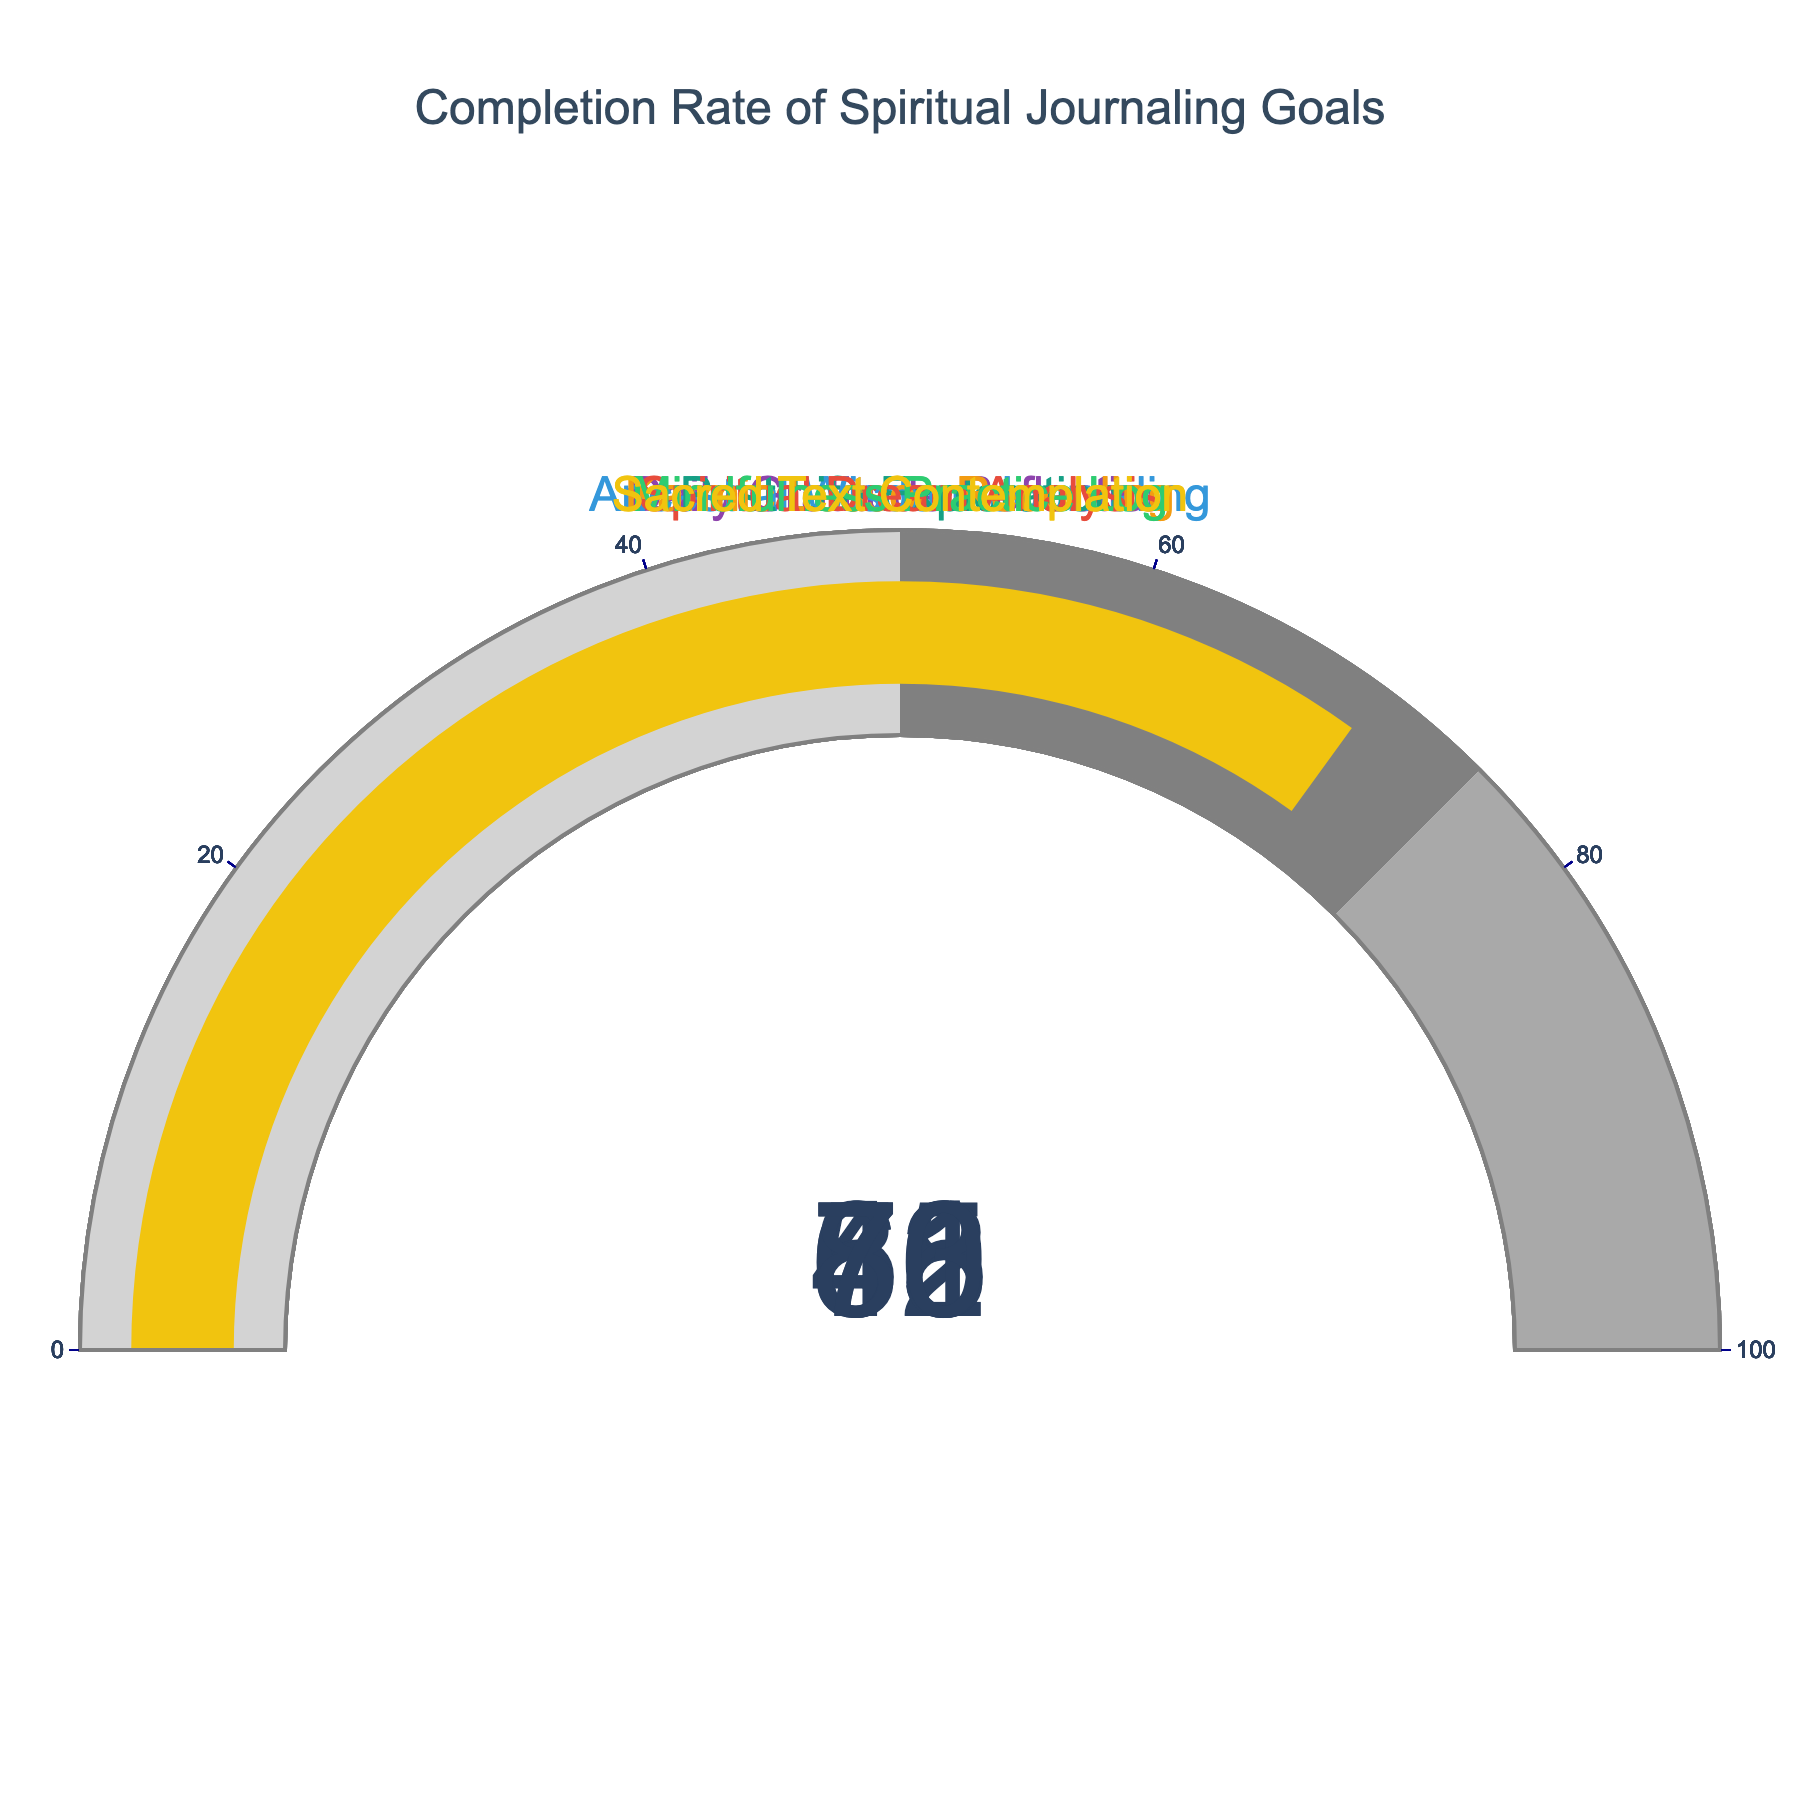What's the highest completion rate displayed on the gauge charts? Identify the gauge with the highest value. The Mindfulness Practice Log has a completion rate of 83, which is the highest rate shown on the charts.
Answer: 83 How many spiritual journaling goals have a completion rate above 60%? Count the gauges with values greater than 60. There are four goals with completion rates above 60: Daily Gratitude Reflection (78), Ancestral Wisdom Journaling (65), Mindfulness Practice Log (83), and Sacred Text Contemplation (70).
Answer: 4 Which journaling goal has the lowest completion rate? Identify the gauge with the lowest value. The Past Life Exploration goal has the lowest completion rate with 42.
Answer: Past Life Exploration What is the average completion rate of all the spiritual journaling goals? Sum the completion rates and divide by the number of goals. The rates are: 78, 65, 42, 56, 61, 83, and 70. The sum is (78 + 65 + 42 + 56 + 61 + 83 + 70) = 455. There are 7 goals, so the average is 455/7 = 65
Answer: 65 Compare the completion rates of Karmic Lesson Recording and Spiritual Dream Analysis. Which is higher? Identify the values for both goals and compare. Karmic Lesson Recording has a completion rate of 56, while Spiritual Dream Analysis has a rate of 61. 61 is greater than 56.
Answer: Spiritual Dream Analysis What is the total completion rate for the Daily Gratitude Reflection and Sacred Text Contemplation goals combined? Sum the completion rates for these two specific goals. Daily Gratitude Reflection is 78 and Sacred Text Contemplation is 70. The total is 78 + 70 = 148
Answer: 148 What is the median completion rate of the spiritual journaling goals? Arrange the completion rates in numerical order: 42, 56, 61, 65, 70, 78, 83. The median value (middle value) is the fourth value, which is 65.
Answer: 65 Which journaling goal is closest to having a completion rate of 60%? Identify the goal whose completion rate is closest to 60. The Spiritual Dream Analysis goal has a completion rate of 61, which is closest to 60
Answer: Spiritual Dream Analysis 